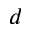Convert formula to latex. <formula><loc_0><loc_0><loc_500><loc_500>d</formula> 